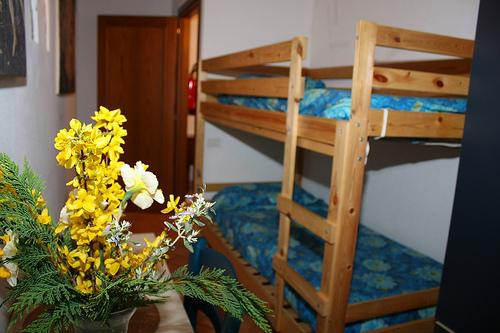Mention any doorway that's visible in the image and describe its surroundings. There's an opened doorway with a brown wooden door and hinges, revealing a red object outside the room. Inform me about any decorative elements hanging on the wall. There is a picture with a wooden frame hanging on the wall, as well as a red fire extinguisher. What kind of blooms can you find in the picture, and where are they? Yellow flowers and a white rose are present, placed in a glass vase on a table and in a flowerpot, respectively. Identify any unusual object interactions in the image. There is a sprig of greenery interacting with the bouquet of yellow flowers, adding contrast and texture to the arrangement. Enumerate the items placed in the bedroom. Items in the bedroom include bunk beds, a blue desk chair, a wooden ladder, a bed with floral spread, a flower vase, a picture on the wall, and a fire extinguisher. Describe the bedding that's visible in the image. There's a made-up bed with a blue bedspread adorned with blue daisies and a floral bedspread with a mix of blue and yellow colors. Count the number of beds in the image and describe their arrangement. There are two bunk beds positioned against the wall, one on top and one below, with a ladder providing access to the top bunk. Analyze the sentiment conveyed by the image. The image conveys a warm and cozy atmosphere, with the comforting presence of flowers, comfortable bedding, and thoughtful decor. Tell me the type of furniture that forms the centerpiece of the image. The centerpiece of the image is a wooden bunk bed with a ladder attached to it. 